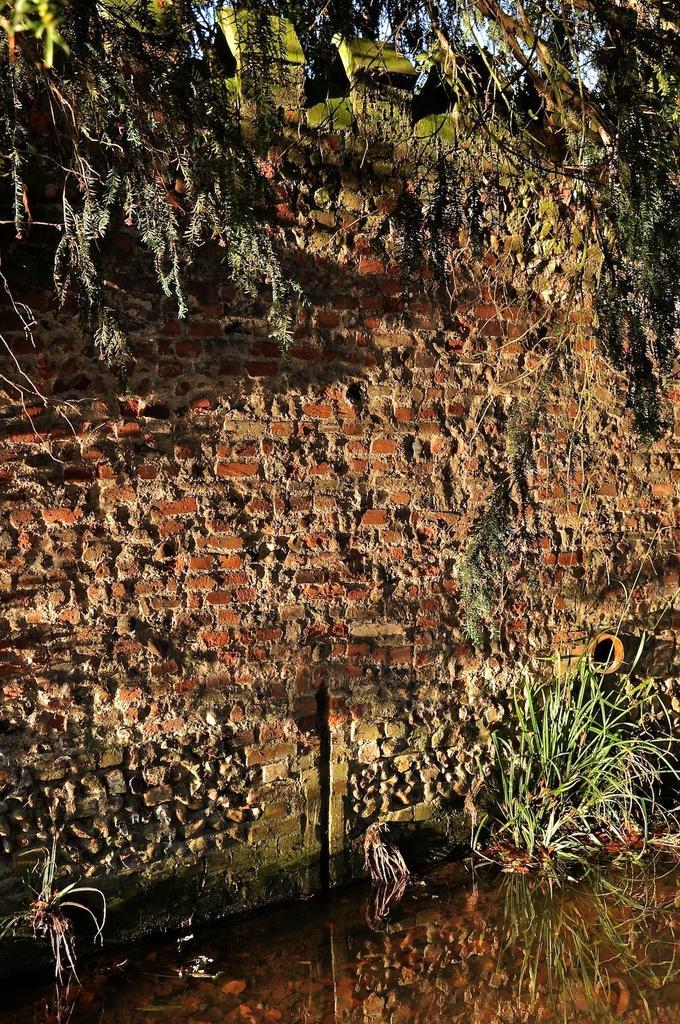Please provide a concise description of this image. In this picture we can see red color brick walls in the middle of the image. In front bottom side we can see small plants. 